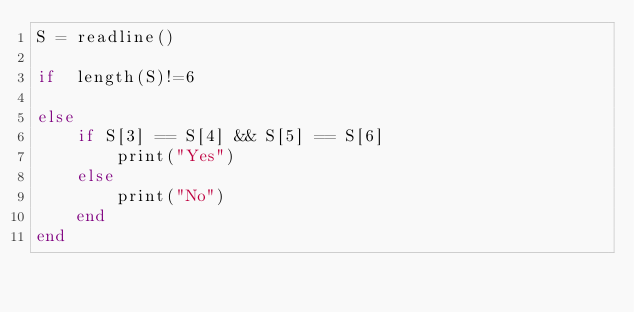<code> <loc_0><loc_0><loc_500><loc_500><_Julia_>S = readline()

if  length(S)!=6
    
else
    if S[3] == S[4] && S[5] == S[6]
        print("Yes")
    else
        print("No")
    end
end</code> 